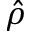<formula> <loc_0><loc_0><loc_500><loc_500>\hat { \rho }</formula> 